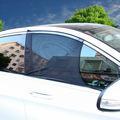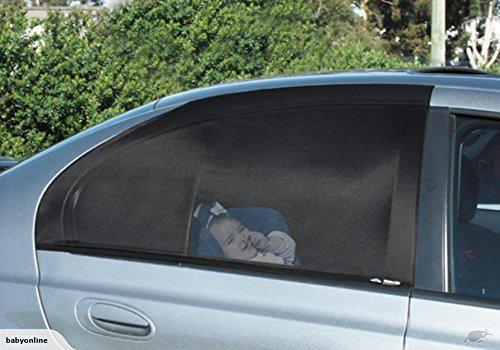The first image is the image on the left, the second image is the image on the right. Given the left and right images, does the statement "In at last one image, a person's hand is shown extending a car window shade." hold true? Answer yes or no. No. 